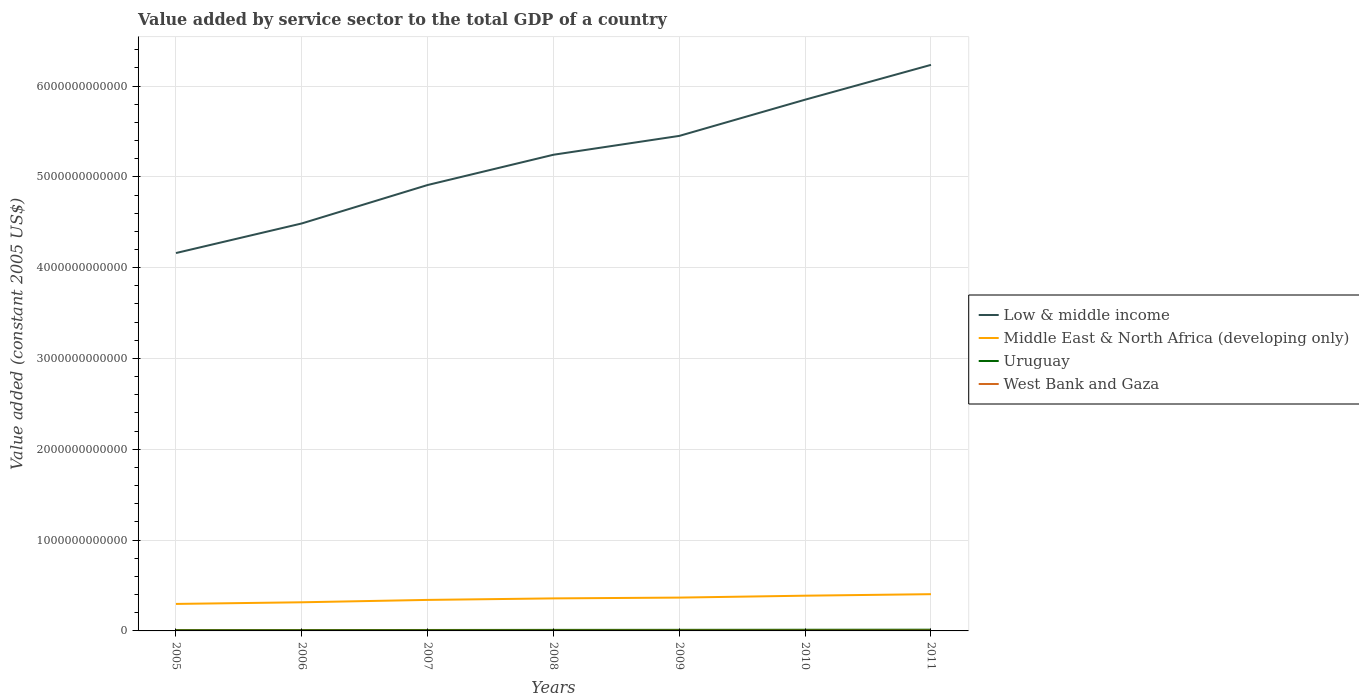Across all years, what is the maximum value added by service sector in Uruguay?
Provide a short and direct response. 9.41e+09. What is the total value added by service sector in Low & middle income in the graph?
Give a very brief answer. -9.40e+11. What is the difference between the highest and the second highest value added by service sector in Low & middle income?
Ensure brevity in your answer.  2.07e+12. What is the difference between the highest and the lowest value added by service sector in Middle East & North Africa (developing only)?
Ensure brevity in your answer.  4. Is the value added by service sector in West Bank and Gaza strictly greater than the value added by service sector in Middle East & North Africa (developing only) over the years?
Your answer should be very brief. Yes. What is the difference between two consecutive major ticks on the Y-axis?
Keep it short and to the point. 1.00e+12. Are the values on the major ticks of Y-axis written in scientific E-notation?
Offer a terse response. No. Does the graph contain grids?
Provide a succinct answer. Yes. Where does the legend appear in the graph?
Your answer should be very brief. Center right. How many legend labels are there?
Ensure brevity in your answer.  4. How are the legend labels stacked?
Your answer should be very brief. Vertical. What is the title of the graph?
Your response must be concise. Value added by service sector to the total GDP of a country. What is the label or title of the Y-axis?
Your answer should be very brief. Value added (constant 2005 US$). What is the Value added (constant 2005 US$) in Low & middle income in 2005?
Provide a succinct answer. 4.16e+12. What is the Value added (constant 2005 US$) of Middle East & North Africa (developing only) in 2005?
Provide a short and direct response. 2.97e+11. What is the Value added (constant 2005 US$) of Uruguay in 2005?
Give a very brief answer. 9.41e+09. What is the Value added (constant 2005 US$) of West Bank and Gaza in 2005?
Offer a terse response. 2.81e+09. What is the Value added (constant 2005 US$) of Low & middle income in 2006?
Give a very brief answer. 4.49e+12. What is the Value added (constant 2005 US$) of Middle East & North Africa (developing only) in 2006?
Make the answer very short. 3.15e+11. What is the Value added (constant 2005 US$) of Uruguay in 2006?
Make the answer very short. 9.68e+09. What is the Value added (constant 2005 US$) in West Bank and Gaza in 2006?
Ensure brevity in your answer.  2.79e+09. What is the Value added (constant 2005 US$) of Low & middle income in 2007?
Your answer should be compact. 4.91e+12. What is the Value added (constant 2005 US$) of Middle East & North Africa (developing only) in 2007?
Offer a very short reply. 3.42e+11. What is the Value added (constant 2005 US$) of Uruguay in 2007?
Provide a succinct answer. 1.03e+1. What is the Value added (constant 2005 US$) in West Bank and Gaza in 2007?
Your answer should be compact. 2.63e+09. What is the Value added (constant 2005 US$) of Low & middle income in 2008?
Keep it short and to the point. 5.24e+12. What is the Value added (constant 2005 US$) of Middle East & North Africa (developing only) in 2008?
Your answer should be very brief. 3.58e+11. What is the Value added (constant 2005 US$) of Uruguay in 2008?
Provide a succinct answer. 1.13e+1. What is the Value added (constant 2005 US$) in West Bank and Gaza in 2008?
Provide a short and direct response. 2.28e+09. What is the Value added (constant 2005 US$) in Low & middle income in 2009?
Ensure brevity in your answer.  5.45e+12. What is the Value added (constant 2005 US$) of Middle East & North Africa (developing only) in 2009?
Your answer should be very brief. 3.67e+11. What is the Value added (constant 2005 US$) in Uruguay in 2009?
Offer a very short reply. 1.18e+1. What is the Value added (constant 2005 US$) of West Bank and Gaza in 2009?
Make the answer very short. 2.69e+09. What is the Value added (constant 2005 US$) of Low & middle income in 2010?
Make the answer very short. 5.85e+12. What is the Value added (constant 2005 US$) of Middle East & North Africa (developing only) in 2010?
Your response must be concise. 3.88e+11. What is the Value added (constant 2005 US$) in Uruguay in 2010?
Your response must be concise. 1.27e+1. What is the Value added (constant 2005 US$) of West Bank and Gaza in 2010?
Offer a very short reply. 2.80e+09. What is the Value added (constant 2005 US$) in Low & middle income in 2011?
Give a very brief answer. 6.23e+12. What is the Value added (constant 2005 US$) in Middle East & North Africa (developing only) in 2011?
Give a very brief answer. 4.05e+11. What is the Value added (constant 2005 US$) in Uruguay in 2011?
Ensure brevity in your answer.  1.34e+1. What is the Value added (constant 2005 US$) in West Bank and Gaza in 2011?
Ensure brevity in your answer.  3.15e+09. Across all years, what is the maximum Value added (constant 2005 US$) in Low & middle income?
Make the answer very short. 6.23e+12. Across all years, what is the maximum Value added (constant 2005 US$) of Middle East & North Africa (developing only)?
Your response must be concise. 4.05e+11. Across all years, what is the maximum Value added (constant 2005 US$) of Uruguay?
Keep it short and to the point. 1.34e+1. Across all years, what is the maximum Value added (constant 2005 US$) of West Bank and Gaza?
Provide a short and direct response. 3.15e+09. Across all years, what is the minimum Value added (constant 2005 US$) in Low & middle income?
Provide a succinct answer. 4.16e+12. Across all years, what is the minimum Value added (constant 2005 US$) of Middle East & North Africa (developing only)?
Give a very brief answer. 2.97e+11. Across all years, what is the minimum Value added (constant 2005 US$) of Uruguay?
Your response must be concise. 9.41e+09. Across all years, what is the minimum Value added (constant 2005 US$) of West Bank and Gaza?
Keep it short and to the point. 2.28e+09. What is the total Value added (constant 2005 US$) in Low & middle income in the graph?
Give a very brief answer. 3.63e+13. What is the total Value added (constant 2005 US$) in Middle East & North Africa (developing only) in the graph?
Your response must be concise. 2.47e+12. What is the total Value added (constant 2005 US$) in Uruguay in the graph?
Give a very brief answer. 7.85e+1. What is the total Value added (constant 2005 US$) of West Bank and Gaza in the graph?
Provide a succinct answer. 1.92e+1. What is the difference between the Value added (constant 2005 US$) of Low & middle income in 2005 and that in 2006?
Offer a terse response. -3.26e+11. What is the difference between the Value added (constant 2005 US$) of Middle East & North Africa (developing only) in 2005 and that in 2006?
Provide a short and direct response. -1.81e+1. What is the difference between the Value added (constant 2005 US$) in Uruguay in 2005 and that in 2006?
Your answer should be very brief. -2.69e+08. What is the difference between the Value added (constant 2005 US$) in West Bank and Gaza in 2005 and that in 2006?
Make the answer very short. 2.14e+07. What is the difference between the Value added (constant 2005 US$) in Low & middle income in 2005 and that in 2007?
Your answer should be compact. -7.49e+11. What is the difference between the Value added (constant 2005 US$) in Middle East & North Africa (developing only) in 2005 and that in 2007?
Provide a succinct answer. -4.43e+1. What is the difference between the Value added (constant 2005 US$) of Uruguay in 2005 and that in 2007?
Your answer should be compact. -8.47e+08. What is the difference between the Value added (constant 2005 US$) of West Bank and Gaza in 2005 and that in 2007?
Your answer should be very brief. 1.74e+08. What is the difference between the Value added (constant 2005 US$) of Low & middle income in 2005 and that in 2008?
Provide a short and direct response. -1.08e+12. What is the difference between the Value added (constant 2005 US$) of Middle East & North Africa (developing only) in 2005 and that in 2008?
Offer a terse response. -6.09e+1. What is the difference between the Value added (constant 2005 US$) in Uruguay in 2005 and that in 2008?
Provide a short and direct response. -1.88e+09. What is the difference between the Value added (constant 2005 US$) of West Bank and Gaza in 2005 and that in 2008?
Provide a short and direct response. 5.28e+08. What is the difference between the Value added (constant 2005 US$) in Low & middle income in 2005 and that in 2009?
Your answer should be compact. -1.29e+12. What is the difference between the Value added (constant 2005 US$) in Middle East & North Africa (developing only) in 2005 and that in 2009?
Offer a very short reply. -6.96e+1. What is the difference between the Value added (constant 2005 US$) of Uruguay in 2005 and that in 2009?
Ensure brevity in your answer.  -2.40e+09. What is the difference between the Value added (constant 2005 US$) in West Bank and Gaza in 2005 and that in 2009?
Give a very brief answer. 1.14e+08. What is the difference between the Value added (constant 2005 US$) of Low & middle income in 2005 and that in 2010?
Offer a very short reply. -1.69e+12. What is the difference between the Value added (constant 2005 US$) of Middle East & North Africa (developing only) in 2005 and that in 2010?
Your answer should be very brief. -9.07e+1. What is the difference between the Value added (constant 2005 US$) in Uruguay in 2005 and that in 2010?
Provide a succinct answer. -3.27e+09. What is the difference between the Value added (constant 2005 US$) in West Bank and Gaza in 2005 and that in 2010?
Keep it short and to the point. 2.78e+06. What is the difference between the Value added (constant 2005 US$) in Low & middle income in 2005 and that in 2011?
Offer a very short reply. -2.07e+12. What is the difference between the Value added (constant 2005 US$) of Middle East & North Africa (developing only) in 2005 and that in 2011?
Keep it short and to the point. -1.07e+11. What is the difference between the Value added (constant 2005 US$) of Uruguay in 2005 and that in 2011?
Make the answer very short. -3.97e+09. What is the difference between the Value added (constant 2005 US$) of West Bank and Gaza in 2005 and that in 2011?
Make the answer very short. -3.43e+08. What is the difference between the Value added (constant 2005 US$) of Low & middle income in 2006 and that in 2007?
Your response must be concise. -4.23e+11. What is the difference between the Value added (constant 2005 US$) of Middle East & North Africa (developing only) in 2006 and that in 2007?
Ensure brevity in your answer.  -2.62e+1. What is the difference between the Value added (constant 2005 US$) of Uruguay in 2006 and that in 2007?
Provide a succinct answer. -5.78e+08. What is the difference between the Value added (constant 2005 US$) of West Bank and Gaza in 2006 and that in 2007?
Make the answer very short. 1.53e+08. What is the difference between the Value added (constant 2005 US$) of Low & middle income in 2006 and that in 2008?
Give a very brief answer. -7.56e+11. What is the difference between the Value added (constant 2005 US$) in Middle East & North Africa (developing only) in 2006 and that in 2008?
Provide a succinct answer. -4.29e+1. What is the difference between the Value added (constant 2005 US$) in Uruguay in 2006 and that in 2008?
Provide a short and direct response. -1.61e+09. What is the difference between the Value added (constant 2005 US$) of West Bank and Gaza in 2006 and that in 2008?
Your answer should be very brief. 5.07e+08. What is the difference between the Value added (constant 2005 US$) in Low & middle income in 2006 and that in 2009?
Offer a very short reply. -9.64e+11. What is the difference between the Value added (constant 2005 US$) in Middle East & North Africa (developing only) in 2006 and that in 2009?
Offer a very short reply. -5.15e+1. What is the difference between the Value added (constant 2005 US$) in Uruguay in 2006 and that in 2009?
Your answer should be very brief. -2.13e+09. What is the difference between the Value added (constant 2005 US$) of West Bank and Gaza in 2006 and that in 2009?
Keep it short and to the point. 9.29e+07. What is the difference between the Value added (constant 2005 US$) in Low & middle income in 2006 and that in 2010?
Offer a very short reply. -1.36e+12. What is the difference between the Value added (constant 2005 US$) in Middle East & North Africa (developing only) in 2006 and that in 2010?
Your answer should be compact. -7.27e+1. What is the difference between the Value added (constant 2005 US$) of Uruguay in 2006 and that in 2010?
Ensure brevity in your answer.  -3.00e+09. What is the difference between the Value added (constant 2005 US$) in West Bank and Gaza in 2006 and that in 2010?
Provide a short and direct response. -1.87e+07. What is the difference between the Value added (constant 2005 US$) in Low & middle income in 2006 and that in 2011?
Keep it short and to the point. -1.75e+12. What is the difference between the Value added (constant 2005 US$) in Middle East & North Africa (developing only) in 2006 and that in 2011?
Ensure brevity in your answer.  -8.93e+1. What is the difference between the Value added (constant 2005 US$) in Uruguay in 2006 and that in 2011?
Your answer should be compact. -3.70e+09. What is the difference between the Value added (constant 2005 US$) in West Bank and Gaza in 2006 and that in 2011?
Your answer should be compact. -3.64e+08. What is the difference between the Value added (constant 2005 US$) of Low & middle income in 2007 and that in 2008?
Make the answer very short. -3.33e+11. What is the difference between the Value added (constant 2005 US$) of Middle East & North Africa (developing only) in 2007 and that in 2008?
Provide a succinct answer. -1.67e+1. What is the difference between the Value added (constant 2005 US$) of Uruguay in 2007 and that in 2008?
Your answer should be very brief. -1.04e+09. What is the difference between the Value added (constant 2005 US$) of West Bank and Gaza in 2007 and that in 2008?
Your answer should be very brief. 3.54e+08. What is the difference between the Value added (constant 2005 US$) of Low & middle income in 2007 and that in 2009?
Offer a terse response. -5.41e+11. What is the difference between the Value added (constant 2005 US$) in Middle East & North Africa (developing only) in 2007 and that in 2009?
Provide a succinct answer. -2.53e+1. What is the difference between the Value added (constant 2005 US$) of Uruguay in 2007 and that in 2009?
Make the answer very short. -1.55e+09. What is the difference between the Value added (constant 2005 US$) in West Bank and Gaza in 2007 and that in 2009?
Ensure brevity in your answer.  -5.98e+07. What is the difference between the Value added (constant 2005 US$) in Low & middle income in 2007 and that in 2010?
Keep it short and to the point. -9.40e+11. What is the difference between the Value added (constant 2005 US$) of Middle East & North Africa (developing only) in 2007 and that in 2010?
Offer a terse response. -4.65e+1. What is the difference between the Value added (constant 2005 US$) in Uruguay in 2007 and that in 2010?
Provide a succinct answer. -2.42e+09. What is the difference between the Value added (constant 2005 US$) of West Bank and Gaza in 2007 and that in 2010?
Your answer should be compact. -1.71e+08. What is the difference between the Value added (constant 2005 US$) of Low & middle income in 2007 and that in 2011?
Offer a very short reply. -1.32e+12. What is the difference between the Value added (constant 2005 US$) in Middle East & North Africa (developing only) in 2007 and that in 2011?
Offer a terse response. -6.31e+1. What is the difference between the Value added (constant 2005 US$) in Uruguay in 2007 and that in 2011?
Ensure brevity in your answer.  -3.13e+09. What is the difference between the Value added (constant 2005 US$) in West Bank and Gaza in 2007 and that in 2011?
Ensure brevity in your answer.  -5.17e+08. What is the difference between the Value added (constant 2005 US$) in Low & middle income in 2008 and that in 2009?
Offer a terse response. -2.08e+11. What is the difference between the Value added (constant 2005 US$) of Middle East & North Africa (developing only) in 2008 and that in 2009?
Your answer should be very brief. -8.68e+09. What is the difference between the Value added (constant 2005 US$) in Uruguay in 2008 and that in 2009?
Provide a short and direct response. -5.17e+08. What is the difference between the Value added (constant 2005 US$) of West Bank and Gaza in 2008 and that in 2009?
Ensure brevity in your answer.  -4.14e+08. What is the difference between the Value added (constant 2005 US$) in Low & middle income in 2008 and that in 2010?
Give a very brief answer. -6.06e+11. What is the difference between the Value added (constant 2005 US$) of Middle East & North Africa (developing only) in 2008 and that in 2010?
Your answer should be very brief. -2.98e+1. What is the difference between the Value added (constant 2005 US$) of Uruguay in 2008 and that in 2010?
Your answer should be compact. -1.38e+09. What is the difference between the Value added (constant 2005 US$) in West Bank and Gaza in 2008 and that in 2010?
Offer a terse response. -5.26e+08. What is the difference between the Value added (constant 2005 US$) of Low & middle income in 2008 and that in 2011?
Offer a very short reply. -9.90e+11. What is the difference between the Value added (constant 2005 US$) of Middle East & North Africa (developing only) in 2008 and that in 2011?
Offer a very short reply. -4.64e+1. What is the difference between the Value added (constant 2005 US$) of Uruguay in 2008 and that in 2011?
Provide a short and direct response. -2.09e+09. What is the difference between the Value added (constant 2005 US$) in West Bank and Gaza in 2008 and that in 2011?
Provide a short and direct response. -8.71e+08. What is the difference between the Value added (constant 2005 US$) in Low & middle income in 2009 and that in 2010?
Ensure brevity in your answer.  -3.99e+11. What is the difference between the Value added (constant 2005 US$) in Middle East & North Africa (developing only) in 2009 and that in 2010?
Provide a succinct answer. -2.12e+1. What is the difference between the Value added (constant 2005 US$) of Uruguay in 2009 and that in 2010?
Offer a terse response. -8.67e+08. What is the difference between the Value added (constant 2005 US$) of West Bank and Gaza in 2009 and that in 2010?
Ensure brevity in your answer.  -1.12e+08. What is the difference between the Value added (constant 2005 US$) of Low & middle income in 2009 and that in 2011?
Offer a terse response. -7.82e+11. What is the difference between the Value added (constant 2005 US$) in Middle East & North Africa (developing only) in 2009 and that in 2011?
Provide a succinct answer. -3.78e+1. What is the difference between the Value added (constant 2005 US$) of Uruguay in 2009 and that in 2011?
Provide a succinct answer. -1.57e+09. What is the difference between the Value added (constant 2005 US$) of West Bank and Gaza in 2009 and that in 2011?
Provide a short and direct response. -4.57e+08. What is the difference between the Value added (constant 2005 US$) of Low & middle income in 2010 and that in 2011?
Offer a terse response. -3.83e+11. What is the difference between the Value added (constant 2005 US$) in Middle East & North Africa (developing only) in 2010 and that in 2011?
Provide a short and direct response. -1.66e+1. What is the difference between the Value added (constant 2005 US$) of Uruguay in 2010 and that in 2011?
Your answer should be compact. -7.06e+08. What is the difference between the Value added (constant 2005 US$) in West Bank and Gaza in 2010 and that in 2011?
Give a very brief answer. -3.45e+08. What is the difference between the Value added (constant 2005 US$) in Low & middle income in 2005 and the Value added (constant 2005 US$) in Middle East & North Africa (developing only) in 2006?
Keep it short and to the point. 3.85e+12. What is the difference between the Value added (constant 2005 US$) of Low & middle income in 2005 and the Value added (constant 2005 US$) of Uruguay in 2006?
Make the answer very short. 4.15e+12. What is the difference between the Value added (constant 2005 US$) of Low & middle income in 2005 and the Value added (constant 2005 US$) of West Bank and Gaza in 2006?
Offer a terse response. 4.16e+12. What is the difference between the Value added (constant 2005 US$) in Middle East & North Africa (developing only) in 2005 and the Value added (constant 2005 US$) in Uruguay in 2006?
Make the answer very short. 2.88e+11. What is the difference between the Value added (constant 2005 US$) in Middle East & North Africa (developing only) in 2005 and the Value added (constant 2005 US$) in West Bank and Gaza in 2006?
Your answer should be compact. 2.95e+11. What is the difference between the Value added (constant 2005 US$) in Uruguay in 2005 and the Value added (constant 2005 US$) in West Bank and Gaza in 2006?
Provide a succinct answer. 6.62e+09. What is the difference between the Value added (constant 2005 US$) in Low & middle income in 2005 and the Value added (constant 2005 US$) in Middle East & North Africa (developing only) in 2007?
Keep it short and to the point. 3.82e+12. What is the difference between the Value added (constant 2005 US$) in Low & middle income in 2005 and the Value added (constant 2005 US$) in Uruguay in 2007?
Give a very brief answer. 4.15e+12. What is the difference between the Value added (constant 2005 US$) of Low & middle income in 2005 and the Value added (constant 2005 US$) of West Bank and Gaza in 2007?
Make the answer very short. 4.16e+12. What is the difference between the Value added (constant 2005 US$) in Middle East & North Africa (developing only) in 2005 and the Value added (constant 2005 US$) in Uruguay in 2007?
Offer a very short reply. 2.87e+11. What is the difference between the Value added (constant 2005 US$) in Middle East & North Africa (developing only) in 2005 and the Value added (constant 2005 US$) in West Bank and Gaza in 2007?
Keep it short and to the point. 2.95e+11. What is the difference between the Value added (constant 2005 US$) of Uruguay in 2005 and the Value added (constant 2005 US$) of West Bank and Gaza in 2007?
Offer a very short reply. 6.78e+09. What is the difference between the Value added (constant 2005 US$) of Low & middle income in 2005 and the Value added (constant 2005 US$) of Middle East & North Africa (developing only) in 2008?
Offer a terse response. 3.80e+12. What is the difference between the Value added (constant 2005 US$) in Low & middle income in 2005 and the Value added (constant 2005 US$) in Uruguay in 2008?
Your response must be concise. 4.15e+12. What is the difference between the Value added (constant 2005 US$) of Low & middle income in 2005 and the Value added (constant 2005 US$) of West Bank and Gaza in 2008?
Your answer should be very brief. 4.16e+12. What is the difference between the Value added (constant 2005 US$) of Middle East & North Africa (developing only) in 2005 and the Value added (constant 2005 US$) of Uruguay in 2008?
Your answer should be very brief. 2.86e+11. What is the difference between the Value added (constant 2005 US$) in Middle East & North Africa (developing only) in 2005 and the Value added (constant 2005 US$) in West Bank and Gaza in 2008?
Make the answer very short. 2.95e+11. What is the difference between the Value added (constant 2005 US$) of Uruguay in 2005 and the Value added (constant 2005 US$) of West Bank and Gaza in 2008?
Give a very brief answer. 7.13e+09. What is the difference between the Value added (constant 2005 US$) in Low & middle income in 2005 and the Value added (constant 2005 US$) in Middle East & North Africa (developing only) in 2009?
Your response must be concise. 3.79e+12. What is the difference between the Value added (constant 2005 US$) in Low & middle income in 2005 and the Value added (constant 2005 US$) in Uruguay in 2009?
Offer a terse response. 4.15e+12. What is the difference between the Value added (constant 2005 US$) of Low & middle income in 2005 and the Value added (constant 2005 US$) of West Bank and Gaza in 2009?
Keep it short and to the point. 4.16e+12. What is the difference between the Value added (constant 2005 US$) in Middle East & North Africa (developing only) in 2005 and the Value added (constant 2005 US$) in Uruguay in 2009?
Ensure brevity in your answer.  2.85e+11. What is the difference between the Value added (constant 2005 US$) of Middle East & North Africa (developing only) in 2005 and the Value added (constant 2005 US$) of West Bank and Gaza in 2009?
Your answer should be very brief. 2.95e+11. What is the difference between the Value added (constant 2005 US$) in Uruguay in 2005 and the Value added (constant 2005 US$) in West Bank and Gaza in 2009?
Make the answer very short. 6.72e+09. What is the difference between the Value added (constant 2005 US$) in Low & middle income in 2005 and the Value added (constant 2005 US$) in Middle East & North Africa (developing only) in 2010?
Make the answer very short. 3.77e+12. What is the difference between the Value added (constant 2005 US$) of Low & middle income in 2005 and the Value added (constant 2005 US$) of Uruguay in 2010?
Your answer should be very brief. 4.15e+12. What is the difference between the Value added (constant 2005 US$) of Low & middle income in 2005 and the Value added (constant 2005 US$) of West Bank and Gaza in 2010?
Your answer should be very brief. 4.16e+12. What is the difference between the Value added (constant 2005 US$) in Middle East & North Africa (developing only) in 2005 and the Value added (constant 2005 US$) in Uruguay in 2010?
Keep it short and to the point. 2.85e+11. What is the difference between the Value added (constant 2005 US$) of Middle East & North Africa (developing only) in 2005 and the Value added (constant 2005 US$) of West Bank and Gaza in 2010?
Make the answer very short. 2.95e+11. What is the difference between the Value added (constant 2005 US$) in Uruguay in 2005 and the Value added (constant 2005 US$) in West Bank and Gaza in 2010?
Provide a succinct answer. 6.61e+09. What is the difference between the Value added (constant 2005 US$) of Low & middle income in 2005 and the Value added (constant 2005 US$) of Middle East & North Africa (developing only) in 2011?
Keep it short and to the point. 3.76e+12. What is the difference between the Value added (constant 2005 US$) in Low & middle income in 2005 and the Value added (constant 2005 US$) in Uruguay in 2011?
Ensure brevity in your answer.  4.15e+12. What is the difference between the Value added (constant 2005 US$) in Low & middle income in 2005 and the Value added (constant 2005 US$) in West Bank and Gaza in 2011?
Make the answer very short. 4.16e+12. What is the difference between the Value added (constant 2005 US$) in Middle East & North Africa (developing only) in 2005 and the Value added (constant 2005 US$) in Uruguay in 2011?
Keep it short and to the point. 2.84e+11. What is the difference between the Value added (constant 2005 US$) of Middle East & North Africa (developing only) in 2005 and the Value added (constant 2005 US$) of West Bank and Gaza in 2011?
Offer a very short reply. 2.94e+11. What is the difference between the Value added (constant 2005 US$) of Uruguay in 2005 and the Value added (constant 2005 US$) of West Bank and Gaza in 2011?
Give a very brief answer. 6.26e+09. What is the difference between the Value added (constant 2005 US$) of Low & middle income in 2006 and the Value added (constant 2005 US$) of Middle East & North Africa (developing only) in 2007?
Keep it short and to the point. 4.15e+12. What is the difference between the Value added (constant 2005 US$) in Low & middle income in 2006 and the Value added (constant 2005 US$) in Uruguay in 2007?
Provide a short and direct response. 4.48e+12. What is the difference between the Value added (constant 2005 US$) in Low & middle income in 2006 and the Value added (constant 2005 US$) in West Bank and Gaza in 2007?
Offer a very short reply. 4.48e+12. What is the difference between the Value added (constant 2005 US$) of Middle East & North Africa (developing only) in 2006 and the Value added (constant 2005 US$) of Uruguay in 2007?
Keep it short and to the point. 3.05e+11. What is the difference between the Value added (constant 2005 US$) of Middle East & North Africa (developing only) in 2006 and the Value added (constant 2005 US$) of West Bank and Gaza in 2007?
Offer a terse response. 3.13e+11. What is the difference between the Value added (constant 2005 US$) of Uruguay in 2006 and the Value added (constant 2005 US$) of West Bank and Gaza in 2007?
Make the answer very short. 7.05e+09. What is the difference between the Value added (constant 2005 US$) of Low & middle income in 2006 and the Value added (constant 2005 US$) of Middle East & North Africa (developing only) in 2008?
Your response must be concise. 4.13e+12. What is the difference between the Value added (constant 2005 US$) of Low & middle income in 2006 and the Value added (constant 2005 US$) of Uruguay in 2008?
Offer a very short reply. 4.48e+12. What is the difference between the Value added (constant 2005 US$) of Low & middle income in 2006 and the Value added (constant 2005 US$) of West Bank and Gaza in 2008?
Ensure brevity in your answer.  4.48e+12. What is the difference between the Value added (constant 2005 US$) in Middle East & North Africa (developing only) in 2006 and the Value added (constant 2005 US$) in Uruguay in 2008?
Give a very brief answer. 3.04e+11. What is the difference between the Value added (constant 2005 US$) in Middle East & North Africa (developing only) in 2006 and the Value added (constant 2005 US$) in West Bank and Gaza in 2008?
Offer a terse response. 3.13e+11. What is the difference between the Value added (constant 2005 US$) of Uruguay in 2006 and the Value added (constant 2005 US$) of West Bank and Gaza in 2008?
Give a very brief answer. 7.40e+09. What is the difference between the Value added (constant 2005 US$) in Low & middle income in 2006 and the Value added (constant 2005 US$) in Middle East & North Africa (developing only) in 2009?
Offer a very short reply. 4.12e+12. What is the difference between the Value added (constant 2005 US$) of Low & middle income in 2006 and the Value added (constant 2005 US$) of Uruguay in 2009?
Provide a succinct answer. 4.48e+12. What is the difference between the Value added (constant 2005 US$) of Low & middle income in 2006 and the Value added (constant 2005 US$) of West Bank and Gaza in 2009?
Offer a very short reply. 4.48e+12. What is the difference between the Value added (constant 2005 US$) in Middle East & North Africa (developing only) in 2006 and the Value added (constant 2005 US$) in Uruguay in 2009?
Keep it short and to the point. 3.04e+11. What is the difference between the Value added (constant 2005 US$) of Middle East & North Africa (developing only) in 2006 and the Value added (constant 2005 US$) of West Bank and Gaza in 2009?
Offer a very short reply. 3.13e+11. What is the difference between the Value added (constant 2005 US$) of Uruguay in 2006 and the Value added (constant 2005 US$) of West Bank and Gaza in 2009?
Ensure brevity in your answer.  6.99e+09. What is the difference between the Value added (constant 2005 US$) in Low & middle income in 2006 and the Value added (constant 2005 US$) in Middle East & North Africa (developing only) in 2010?
Provide a succinct answer. 4.10e+12. What is the difference between the Value added (constant 2005 US$) in Low & middle income in 2006 and the Value added (constant 2005 US$) in Uruguay in 2010?
Make the answer very short. 4.47e+12. What is the difference between the Value added (constant 2005 US$) in Low & middle income in 2006 and the Value added (constant 2005 US$) in West Bank and Gaza in 2010?
Keep it short and to the point. 4.48e+12. What is the difference between the Value added (constant 2005 US$) of Middle East & North Africa (developing only) in 2006 and the Value added (constant 2005 US$) of Uruguay in 2010?
Offer a terse response. 3.03e+11. What is the difference between the Value added (constant 2005 US$) of Middle East & North Africa (developing only) in 2006 and the Value added (constant 2005 US$) of West Bank and Gaza in 2010?
Offer a very short reply. 3.13e+11. What is the difference between the Value added (constant 2005 US$) of Uruguay in 2006 and the Value added (constant 2005 US$) of West Bank and Gaza in 2010?
Your answer should be very brief. 6.87e+09. What is the difference between the Value added (constant 2005 US$) of Low & middle income in 2006 and the Value added (constant 2005 US$) of Middle East & North Africa (developing only) in 2011?
Provide a short and direct response. 4.08e+12. What is the difference between the Value added (constant 2005 US$) in Low & middle income in 2006 and the Value added (constant 2005 US$) in Uruguay in 2011?
Keep it short and to the point. 4.47e+12. What is the difference between the Value added (constant 2005 US$) in Low & middle income in 2006 and the Value added (constant 2005 US$) in West Bank and Gaza in 2011?
Provide a short and direct response. 4.48e+12. What is the difference between the Value added (constant 2005 US$) of Middle East & North Africa (developing only) in 2006 and the Value added (constant 2005 US$) of Uruguay in 2011?
Offer a terse response. 3.02e+11. What is the difference between the Value added (constant 2005 US$) of Middle East & North Africa (developing only) in 2006 and the Value added (constant 2005 US$) of West Bank and Gaza in 2011?
Your answer should be compact. 3.12e+11. What is the difference between the Value added (constant 2005 US$) in Uruguay in 2006 and the Value added (constant 2005 US$) in West Bank and Gaza in 2011?
Provide a succinct answer. 6.53e+09. What is the difference between the Value added (constant 2005 US$) in Low & middle income in 2007 and the Value added (constant 2005 US$) in Middle East & North Africa (developing only) in 2008?
Provide a short and direct response. 4.55e+12. What is the difference between the Value added (constant 2005 US$) in Low & middle income in 2007 and the Value added (constant 2005 US$) in Uruguay in 2008?
Your answer should be compact. 4.90e+12. What is the difference between the Value added (constant 2005 US$) of Low & middle income in 2007 and the Value added (constant 2005 US$) of West Bank and Gaza in 2008?
Ensure brevity in your answer.  4.91e+12. What is the difference between the Value added (constant 2005 US$) in Middle East & North Africa (developing only) in 2007 and the Value added (constant 2005 US$) in Uruguay in 2008?
Provide a short and direct response. 3.30e+11. What is the difference between the Value added (constant 2005 US$) in Middle East & North Africa (developing only) in 2007 and the Value added (constant 2005 US$) in West Bank and Gaza in 2008?
Give a very brief answer. 3.39e+11. What is the difference between the Value added (constant 2005 US$) of Uruguay in 2007 and the Value added (constant 2005 US$) of West Bank and Gaza in 2008?
Give a very brief answer. 7.98e+09. What is the difference between the Value added (constant 2005 US$) of Low & middle income in 2007 and the Value added (constant 2005 US$) of Middle East & North Africa (developing only) in 2009?
Offer a very short reply. 4.54e+12. What is the difference between the Value added (constant 2005 US$) of Low & middle income in 2007 and the Value added (constant 2005 US$) of Uruguay in 2009?
Provide a succinct answer. 4.90e+12. What is the difference between the Value added (constant 2005 US$) in Low & middle income in 2007 and the Value added (constant 2005 US$) in West Bank and Gaza in 2009?
Offer a very short reply. 4.91e+12. What is the difference between the Value added (constant 2005 US$) of Middle East & North Africa (developing only) in 2007 and the Value added (constant 2005 US$) of Uruguay in 2009?
Provide a succinct answer. 3.30e+11. What is the difference between the Value added (constant 2005 US$) in Middle East & North Africa (developing only) in 2007 and the Value added (constant 2005 US$) in West Bank and Gaza in 2009?
Ensure brevity in your answer.  3.39e+11. What is the difference between the Value added (constant 2005 US$) of Uruguay in 2007 and the Value added (constant 2005 US$) of West Bank and Gaza in 2009?
Give a very brief answer. 7.56e+09. What is the difference between the Value added (constant 2005 US$) of Low & middle income in 2007 and the Value added (constant 2005 US$) of Middle East & North Africa (developing only) in 2010?
Keep it short and to the point. 4.52e+12. What is the difference between the Value added (constant 2005 US$) of Low & middle income in 2007 and the Value added (constant 2005 US$) of Uruguay in 2010?
Offer a terse response. 4.90e+12. What is the difference between the Value added (constant 2005 US$) of Low & middle income in 2007 and the Value added (constant 2005 US$) of West Bank and Gaza in 2010?
Provide a short and direct response. 4.91e+12. What is the difference between the Value added (constant 2005 US$) in Middle East & North Africa (developing only) in 2007 and the Value added (constant 2005 US$) in Uruguay in 2010?
Your answer should be very brief. 3.29e+11. What is the difference between the Value added (constant 2005 US$) of Middle East & North Africa (developing only) in 2007 and the Value added (constant 2005 US$) of West Bank and Gaza in 2010?
Ensure brevity in your answer.  3.39e+11. What is the difference between the Value added (constant 2005 US$) in Uruguay in 2007 and the Value added (constant 2005 US$) in West Bank and Gaza in 2010?
Make the answer very short. 7.45e+09. What is the difference between the Value added (constant 2005 US$) of Low & middle income in 2007 and the Value added (constant 2005 US$) of Middle East & North Africa (developing only) in 2011?
Make the answer very short. 4.51e+12. What is the difference between the Value added (constant 2005 US$) of Low & middle income in 2007 and the Value added (constant 2005 US$) of Uruguay in 2011?
Keep it short and to the point. 4.90e+12. What is the difference between the Value added (constant 2005 US$) in Low & middle income in 2007 and the Value added (constant 2005 US$) in West Bank and Gaza in 2011?
Provide a short and direct response. 4.91e+12. What is the difference between the Value added (constant 2005 US$) in Middle East & North Africa (developing only) in 2007 and the Value added (constant 2005 US$) in Uruguay in 2011?
Give a very brief answer. 3.28e+11. What is the difference between the Value added (constant 2005 US$) of Middle East & North Africa (developing only) in 2007 and the Value added (constant 2005 US$) of West Bank and Gaza in 2011?
Provide a short and direct response. 3.38e+11. What is the difference between the Value added (constant 2005 US$) in Uruguay in 2007 and the Value added (constant 2005 US$) in West Bank and Gaza in 2011?
Your response must be concise. 7.11e+09. What is the difference between the Value added (constant 2005 US$) of Low & middle income in 2008 and the Value added (constant 2005 US$) of Middle East & North Africa (developing only) in 2009?
Your answer should be compact. 4.88e+12. What is the difference between the Value added (constant 2005 US$) of Low & middle income in 2008 and the Value added (constant 2005 US$) of Uruguay in 2009?
Your response must be concise. 5.23e+12. What is the difference between the Value added (constant 2005 US$) of Low & middle income in 2008 and the Value added (constant 2005 US$) of West Bank and Gaza in 2009?
Your response must be concise. 5.24e+12. What is the difference between the Value added (constant 2005 US$) of Middle East & North Africa (developing only) in 2008 and the Value added (constant 2005 US$) of Uruguay in 2009?
Offer a very short reply. 3.46e+11. What is the difference between the Value added (constant 2005 US$) of Middle East & North Africa (developing only) in 2008 and the Value added (constant 2005 US$) of West Bank and Gaza in 2009?
Offer a very short reply. 3.56e+11. What is the difference between the Value added (constant 2005 US$) of Uruguay in 2008 and the Value added (constant 2005 US$) of West Bank and Gaza in 2009?
Give a very brief answer. 8.60e+09. What is the difference between the Value added (constant 2005 US$) of Low & middle income in 2008 and the Value added (constant 2005 US$) of Middle East & North Africa (developing only) in 2010?
Your response must be concise. 4.86e+12. What is the difference between the Value added (constant 2005 US$) in Low & middle income in 2008 and the Value added (constant 2005 US$) in Uruguay in 2010?
Make the answer very short. 5.23e+12. What is the difference between the Value added (constant 2005 US$) of Low & middle income in 2008 and the Value added (constant 2005 US$) of West Bank and Gaza in 2010?
Your answer should be compact. 5.24e+12. What is the difference between the Value added (constant 2005 US$) of Middle East & North Africa (developing only) in 2008 and the Value added (constant 2005 US$) of Uruguay in 2010?
Offer a terse response. 3.46e+11. What is the difference between the Value added (constant 2005 US$) of Middle East & North Africa (developing only) in 2008 and the Value added (constant 2005 US$) of West Bank and Gaza in 2010?
Keep it short and to the point. 3.55e+11. What is the difference between the Value added (constant 2005 US$) of Uruguay in 2008 and the Value added (constant 2005 US$) of West Bank and Gaza in 2010?
Keep it short and to the point. 8.49e+09. What is the difference between the Value added (constant 2005 US$) of Low & middle income in 2008 and the Value added (constant 2005 US$) of Middle East & North Africa (developing only) in 2011?
Your response must be concise. 4.84e+12. What is the difference between the Value added (constant 2005 US$) of Low & middle income in 2008 and the Value added (constant 2005 US$) of Uruguay in 2011?
Provide a short and direct response. 5.23e+12. What is the difference between the Value added (constant 2005 US$) in Low & middle income in 2008 and the Value added (constant 2005 US$) in West Bank and Gaza in 2011?
Offer a very short reply. 5.24e+12. What is the difference between the Value added (constant 2005 US$) in Middle East & North Africa (developing only) in 2008 and the Value added (constant 2005 US$) in Uruguay in 2011?
Provide a succinct answer. 3.45e+11. What is the difference between the Value added (constant 2005 US$) in Middle East & North Africa (developing only) in 2008 and the Value added (constant 2005 US$) in West Bank and Gaza in 2011?
Make the answer very short. 3.55e+11. What is the difference between the Value added (constant 2005 US$) in Uruguay in 2008 and the Value added (constant 2005 US$) in West Bank and Gaza in 2011?
Your answer should be very brief. 8.14e+09. What is the difference between the Value added (constant 2005 US$) in Low & middle income in 2009 and the Value added (constant 2005 US$) in Middle East & North Africa (developing only) in 2010?
Your answer should be very brief. 5.06e+12. What is the difference between the Value added (constant 2005 US$) of Low & middle income in 2009 and the Value added (constant 2005 US$) of Uruguay in 2010?
Offer a terse response. 5.44e+12. What is the difference between the Value added (constant 2005 US$) in Low & middle income in 2009 and the Value added (constant 2005 US$) in West Bank and Gaza in 2010?
Your answer should be very brief. 5.45e+12. What is the difference between the Value added (constant 2005 US$) in Middle East & North Africa (developing only) in 2009 and the Value added (constant 2005 US$) in Uruguay in 2010?
Offer a terse response. 3.54e+11. What is the difference between the Value added (constant 2005 US$) in Middle East & North Africa (developing only) in 2009 and the Value added (constant 2005 US$) in West Bank and Gaza in 2010?
Provide a succinct answer. 3.64e+11. What is the difference between the Value added (constant 2005 US$) of Uruguay in 2009 and the Value added (constant 2005 US$) of West Bank and Gaza in 2010?
Provide a succinct answer. 9.01e+09. What is the difference between the Value added (constant 2005 US$) of Low & middle income in 2009 and the Value added (constant 2005 US$) of Middle East & North Africa (developing only) in 2011?
Provide a short and direct response. 5.05e+12. What is the difference between the Value added (constant 2005 US$) of Low & middle income in 2009 and the Value added (constant 2005 US$) of Uruguay in 2011?
Your answer should be compact. 5.44e+12. What is the difference between the Value added (constant 2005 US$) in Low & middle income in 2009 and the Value added (constant 2005 US$) in West Bank and Gaza in 2011?
Your answer should be very brief. 5.45e+12. What is the difference between the Value added (constant 2005 US$) of Middle East & North Africa (developing only) in 2009 and the Value added (constant 2005 US$) of Uruguay in 2011?
Make the answer very short. 3.54e+11. What is the difference between the Value added (constant 2005 US$) of Middle East & North Africa (developing only) in 2009 and the Value added (constant 2005 US$) of West Bank and Gaza in 2011?
Provide a short and direct response. 3.64e+11. What is the difference between the Value added (constant 2005 US$) of Uruguay in 2009 and the Value added (constant 2005 US$) of West Bank and Gaza in 2011?
Provide a succinct answer. 8.66e+09. What is the difference between the Value added (constant 2005 US$) of Low & middle income in 2010 and the Value added (constant 2005 US$) of Middle East & North Africa (developing only) in 2011?
Your answer should be very brief. 5.44e+12. What is the difference between the Value added (constant 2005 US$) in Low & middle income in 2010 and the Value added (constant 2005 US$) in Uruguay in 2011?
Your answer should be very brief. 5.84e+12. What is the difference between the Value added (constant 2005 US$) in Low & middle income in 2010 and the Value added (constant 2005 US$) in West Bank and Gaza in 2011?
Provide a short and direct response. 5.85e+12. What is the difference between the Value added (constant 2005 US$) of Middle East & North Africa (developing only) in 2010 and the Value added (constant 2005 US$) of Uruguay in 2011?
Provide a short and direct response. 3.75e+11. What is the difference between the Value added (constant 2005 US$) of Middle East & North Africa (developing only) in 2010 and the Value added (constant 2005 US$) of West Bank and Gaza in 2011?
Your answer should be compact. 3.85e+11. What is the difference between the Value added (constant 2005 US$) in Uruguay in 2010 and the Value added (constant 2005 US$) in West Bank and Gaza in 2011?
Make the answer very short. 9.53e+09. What is the average Value added (constant 2005 US$) of Low & middle income per year?
Provide a succinct answer. 5.19e+12. What is the average Value added (constant 2005 US$) in Middle East & North Africa (developing only) per year?
Keep it short and to the point. 3.53e+11. What is the average Value added (constant 2005 US$) in Uruguay per year?
Provide a succinct answer. 1.12e+1. What is the average Value added (constant 2005 US$) in West Bank and Gaza per year?
Provide a succinct answer. 2.74e+09. In the year 2005, what is the difference between the Value added (constant 2005 US$) of Low & middle income and Value added (constant 2005 US$) of Middle East & North Africa (developing only)?
Give a very brief answer. 3.86e+12. In the year 2005, what is the difference between the Value added (constant 2005 US$) of Low & middle income and Value added (constant 2005 US$) of Uruguay?
Your response must be concise. 4.15e+12. In the year 2005, what is the difference between the Value added (constant 2005 US$) of Low & middle income and Value added (constant 2005 US$) of West Bank and Gaza?
Offer a very short reply. 4.16e+12. In the year 2005, what is the difference between the Value added (constant 2005 US$) in Middle East & North Africa (developing only) and Value added (constant 2005 US$) in Uruguay?
Offer a very short reply. 2.88e+11. In the year 2005, what is the difference between the Value added (constant 2005 US$) in Middle East & North Africa (developing only) and Value added (constant 2005 US$) in West Bank and Gaza?
Your response must be concise. 2.95e+11. In the year 2005, what is the difference between the Value added (constant 2005 US$) in Uruguay and Value added (constant 2005 US$) in West Bank and Gaza?
Ensure brevity in your answer.  6.60e+09. In the year 2006, what is the difference between the Value added (constant 2005 US$) in Low & middle income and Value added (constant 2005 US$) in Middle East & North Africa (developing only)?
Offer a terse response. 4.17e+12. In the year 2006, what is the difference between the Value added (constant 2005 US$) in Low & middle income and Value added (constant 2005 US$) in Uruguay?
Offer a terse response. 4.48e+12. In the year 2006, what is the difference between the Value added (constant 2005 US$) of Low & middle income and Value added (constant 2005 US$) of West Bank and Gaza?
Your answer should be very brief. 4.48e+12. In the year 2006, what is the difference between the Value added (constant 2005 US$) in Middle East & North Africa (developing only) and Value added (constant 2005 US$) in Uruguay?
Keep it short and to the point. 3.06e+11. In the year 2006, what is the difference between the Value added (constant 2005 US$) of Middle East & North Africa (developing only) and Value added (constant 2005 US$) of West Bank and Gaza?
Provide a short and direct response. 3.13e+11. In the year 2006, what is the difference between the Value added (constant 2005 US$) in Uruguay and Value added (constant 2005 US$) in West Bank and Gaza?
Your answer should be compact. 6.89e+09. In the year 2007, what is the difference between the Value added (constant 2005 US$) in Low & middle income and Value added (constant 2005 US$) in Middle East & North Africa (developing only)?
Give a very brief answer. 4.57e+12. In the year 2007, what is the difference between the Value added (constant 2005 US$) in Low & middle income and Value added (constant 2005 US$) in Uruguay?
Your answer should be compact. 4.90e+12. In the year 2007, what is the difference between the Value added (constant 2005 US$) in Low & middle income and Value added (constant 2005 US$) in West Bank and Gaza?
Your answer should be very brief. 4.91e+12. In the year 2007, what is the difference between the Value added (constant 2005 US$) in Middle East & North Africa (developing only) and Value added (constant 2005 US$) in Uruguay?
Provide a short and direct response. 3.31e+11. In the year 2007, what is the difference between the Value added (constant 2005 US$) in Middle East & North Africa (developing only) and Value added (constant 2005 US$) in West Bank and Gaza?
Your answer should be compact. 3.39e+11. In the year 2007, what is the difference between the Value added (constant 2005 US$) of Uruguay and Value added (constant 2005 US$) of West Bank and Gaza?
Provide a succinct answer. 7.62e+09. In the year 2008, what is the difference between the Value added (constant 2005 US$) of Low & middle income and Value added (constant 2005 US$) of Middle East & North Africa (developing only)?
Provide a succinct answer. 4.89e+12. In the year 2008, what is the difference between the Value added (constant 2005 US$) in Low & middle income and Value added (constant 2005 US$) in Uruguay?
Give a very brief answer. 5.23e+12. In the year 2008, what is the difference between the Value added (constant 2005 US$) of Low & middle income and Value added (constant 2005 US$) of West Bank and Gaza?
Offer a very short reply. 5.24e+12. In the year 2008, what is the difference between the Value added (constant 2005 US$) in Middle East & North Africa (developing only) and Value added (constant 2005 US$) in Uruguay?
Make the answer very short. 3.47e+11. In the year 2008, what is the difference between the Value added (constant 2005 US$) in Middle East & North Africa (developing only) and Value added (constant 2005 US$) in West Bank and Gaza?
Provide a short and direct response. 3.56e+11. In the year 2008, what is the difference between the Value added (constant 2005 US$) in Uruguay and Value added (constant 2005 US$) in West Bank and Gaza?
Provide a short and direct response. 9.01e+09. In the year 2009, what is the difference between the Value added (constant 2005 US$) in Low & middle income and Value added (constant 2005 US$) in Middle East & North Africa (developing only)?
Offer a very short reply. 5.08e+12. In the year 2009, what is the difference between the Value added (constant 2005 US$) in Low & middle income and Value added (constant 2005 US$) in Uruguay?
Make the answer very short. 5.44e+12. In the year 2009, what is the difference between the Value added (constant 2005 US$) in Low & middle income and Value added (constant 2005 US$) in West Bank and Gaza?
Your answer should be compact. 5.45e+12. In the year 2009, what is the difference between the Value added (constant 2005 US$) in Middle East & North Africa (developing only) and Value added (constant 2005 US$) in Uruguay?
Your response must be concise. 3.55e+11. In the year 2009, what is the difference between the Value added (constant 2005 US$) in Middle East & North Africa (developing only) and Value added (constant 2005 US$) in West Bank and Gaza?
Your answer should be very brief. 3.64e+11. In the year 2009, what is the difference between the Value added (constant 2005 US$) of Uruguay and Value added (constant 2005 US$) of West Bank and Gaza?
Your answer should be compact. 9.12e+09. In the year 2010, what is the difference between the Value added (constant 2005 US$) in Low & middle income and Value added (constant 2005 US$) in Middle East & North Africa (developing only)?
Give a very brief answer. 5.46e+12. In the year 2010, what is the difference between the Value added (constant 2005 US$) of Low & middle income and Value added (constant 2005 US$) of Uruguay?
Offer a terse response. 5.84e+12. In the year 2010, what is the difference between the Value added (constant 2005 US$) of Low & middle income and Value added (constant 2005 US$) of West Bank and Gaza?
Make the answer very short. 5.85e+12. In the year 2010, what is the difference between the Value added (constant 2005 US$) in Middle East & North Africa (developing only) and Value added (constant 2005 US$) in Uruguay?
Make the answer very short. 3.75e+11. In the year 2010, what is the difference between the Value added (constant 2005 US$) of Middle East & North Africa (developing only) and Value added (constant 2005 US$) of West Bank and Gaza?
Offer a very short reply. 3.85e+11. In the year 2010, what is the difference between the Value added (constant 2005 US$) in Uruguay and Value added (constant 2005 US$) in West Bank and Gaza?
Provide a succinct answer. 9.87e+09. In the year 2011, what is the difference between the Value added (constant 2005 US$) in Low & middle income and Value added (constant 2005 US$) in Middle East & North Africa (developing only)?
Provide a short and direct response. 5.83e+12. In the year 2011, what is the difference between the Value added (constant 2005 US$) in Low & middle income and Value added (constant 2005 US$) in Uruguay?
Offer a terse response. 6.22e+12. In the year 2011, what is the difference between the Value added (constant 2005 US$) of Low & middle income and Value added (constant 2005 US$) of West Bank and Gaza?
Provide a succinct answer. 6.23e+12. In the year 2011, what is the difference between the Value added (constant 2005 US$) in Middle East & North Africa (developing only) and Value added (constant 2005 US$) in Uruguay?
Ensure brevity in your answer.  3.91e+11. In the year 2011, what is the difference between the Value added (constant 2005 US$) of Middle East & North Africa (developing only) and Value added (constant 2005 US$) of West Bank and Gaza?
Keep it short and to the point. 4.01e+11. In the year 2011, what is the difference between the Value added (constant 2005 US$) in Uruguay and Value added (constant 2005 US$) in West Bank and Gaza?
Your answer should be very brief. 1.02e+1. What is the ratio of the Value added (constant 2005 US$) of Low & middle income in 2005 to that in 2006?
Provide a succinct answer. 0.93. What is the ratio of the Value added (constant 2005 US$) of Middle East & North Africa (developing only) in 2005 to that in 2006?
Your answer should be compact. 0.94. What is the ratio of the Value added (constant 2005 US$) of Uruguay in 2005 to that in 2006?
Provide a short and direct response. 0.97. What is the ratio of the Value added (constant 2005 US$) of West Bank and Gaza in 2005 to that in 2006?
Offer a terse response. 1.01. What is the ratio of the Value added (constant 2005 US$) in Low & middle income in 2005 to that in 2007?
Make the answer very short. 0.85. What is the ratio of the Value added (constant 2005 US$) of Middle East & North Africa (developing only) in 2005 to that in 2007?
Give a very brief answer. 0.87. What is the ratio of the Value added (constant 2005 US$) in Uruguay in 2005 to that in 2007?
Offer a very short reply. 0.92. What is the ratio of the Value added (constant 2005 US$) of West Bank and Gaza in 2005 to that in 2007?
Provide a short and direct response. 1.07. What is the ratio of the Value added (constant 2005 US$) in Low & middle income in 2005 to that in 2008?
Provide a succinct answer. 0.79. What is the ratio of the Value added (constant 2005 US$) of Middle East & North Africa (developing only) in 2005 to that in 2008?
Give a very brief answer. 0.83. What is the ratio of the Value added (constant 2005 US$) in Uruguay in 2005 to that in 2008?
Offer a terse response. 0.83. What is the ratio of the Value added (constant 2005 US$) in West Bank and Gaza in 2005 to that in 2008?
Offer a terse response. 1.23. What is the ratio of the Value added (constant 2005 US$) of Low & middle income in 2005 to that in 2009?
Your answer should be very brief. 0.76. What is the ratio of the Value added (constant 2005 US$) in Middle East & North Africa (developing only) in 2005 to that in 2009?
Your answer should be compact. 0.81. What is the ratio of the Value added (constant 2005 US$) in Uruguay in 2005 to that in 2009?
Make the answer very short. 0.8. What is the ratio of the Value added (constant 2005 US$) of West Bank and Gaza in 2005 to that in 2009?
Your answer should be compact. 1.04. What is the ratio of the Value added (constant 2005 US$) in Low & middle income in 2005 to that in 2010?
Offer a very short reply. 0.71. What is the ratio of the Value added (constant 2005 US$) in Middle East & North Africa (developing only) in 2005 to that in 2010?
Ensure brevity in your answer.  0.77. What is the ratio of the Value added (constant 2005 US$) in Uruguay in 2005 to that in 2010?
Keep it short and to the point. 0.74. What is the ratio of the Value added (constant 2005 US$) of West Bank and Gaza in 2005 to that in 2010?
Offer a very short reply. 1. What is the ratio of the Value added (constant 2005 US$) in Low & middle income in 2005 to that in 2011?
Your answer should be compact. 0.67. What is the ratio of the Value added (constant 2005 US$) in Middle East & North Africa (developing only) in 2005 to that in 2011?
Your answer should be very brief. 0.73. What is the ratio of the Value added (constant 2005 US$) in Uruguay in 2005 to that in 2011?
Give a very brief answer. 0.7. What is the ratio of the Value added (constant 2005 US$) of West Bank and Gaza in 2005 to that in 2011?
Your response must be concise. 0.89. What is the ratio of the Value added (constant 2005 US$) in Low & middle income in 2006 to that in 2007?
Provide a short and direct response. 0.91. What is the ratio of the Value added (constant 2005 US$) of Middle East & North Africa (developing only) in 2006 to that in 2007?
Offer a terse response. 0.92. What is the ratio of the Value added (constant 2005 US$) in Uruguay in 2006 to that in 2007?
Your answer should be compact. 0.94. What is the ratio of the Value added (constant 2005 US$) of West Bank and Gaza in 2006 to that in 2007?
Give a very brief answer. 1.06. What is the ratio of the Value added (constant 2005 US$) of Low & middle income in 2006 to that in 2008?
Ensure brevity in your answer.  0.86. What is the ratio of the Value added (constant 2005 US$) in Middle East & North Africa (developing only) in 2006 to that in 2008?
Offer a terse response. 0.88. What is the ratio of the Value added (constant 2005 US$) in Uruguay in 2006 to that in 2008?
Your answer should be very brief. 0.86. What is the ratio of the Value added (constant 2005 US$) in West Bank and Gaza in 2006 to that in 2008?
Provide a succinct answer. 1.22. What is the ratio of the Value added (constant 2005 US$) of Low & middle income in 2006 to that in 2009?
Ensure brevity in your answer.  0.82. What is the ratio of the Value added (constant 2005 US$) in Middle East & North Africa (developing only) in 2006 to that in 2009?
Provide a short and direct response. 0.86. What is the ratio of the Value added (constant 2005 US$) of Uruguay in 2006 to that in 2009?
Offer a very short reply. 0.82. What is the ratio of the Value added (constant 2005 US$) in West Bank and Gaza in 2006 to that in 2009?
Keep it short and to the point. 1.03. What is the ratio of the Value added (constant 2005 US$) in Low & middle income in 2006 to that in 2010?
Your response must be concise. 0.77. What is the ratio of the Value added (constant 2005 US$) of Middle East & North Africa (developing only) in 2006 to that in 2010?
Ensure brevity in your answer.  0.81. What is the ratio of the Value added (constant 2005 US$) in Uruguay in 2006 to that in 2010?
Provide a short and direct response. 0.76. What is the ratio of the Value added (constant 2005 US$) in West Bank and Gaza in 2006 to that in 2010?
Offer a very short reply. 0.99. What is the ratio of the Value added (constant 2005 US$) of Low & middle income in 2006 to that in 2011?
Provide a short and direct response. 0.72. What is the ratio of the Value added (constant 2005 US$) of Middle East & North Africa (developing only) in 2006 to that in 2011?
Make the answer very short. 0.78. What is the ratio of the Value added (constant 2005 US$) of Uruguay in 2006 to that in 2011?
Provide a short and direct response. 0.72. What is the ratio of the Value added (constant 2005 US$) in West Bank and Gaza in 2006 to that in 2011?
Ensure brevity in your answer.  0.88. What is the ratio of the Value added (constant 2005 US$) of Low & middle income in 2007 to that in 2008?
Ensure brevity in your answer.  0.94. What is the ratio of the Value added (constant 2005 US$) in Middle East & North Africa (developing only) in 2007 to that in 2008?
Give a very brief answer. 0.95. What is the ratio of the Value added (constant 2005 US$) in Uruguay in 2007 to that in 2008?
Ensure brevity in your answer.  0.91. What is the ratio of the Value added (constant 2005 US$) in West Bank and Gaza in 2007 to that in 2008?
Your answer should be compact. 1.16. What is the ratio of the Value added (constant 2005 US$) in Low & middle income in 2007 to that in 2009?
Your response must be concise. 0.9. What is the ratio of the Value added (constant 2005 US$) in Middle East & North Africa (developing only) in 2007 to that in 2009?
Make the answer very short. 0.93. What is the ratio of the Value added (constant 2005 US$) of Uruguay in 2007 to that in 2009?
Your response must be concise. 0.87. What is the ratio of the Value added (constant 2005 US$) of West Bank and Gaza in 2007 to that in 2009?
Your response must be concise. 0.98. What is the ratio of the Value added (constant 2005 US$) in Low & middle income in 2007 to that in 2010?
Make the answer very short. 0.84. What is the ratio of the Value added (constant 2005 US$) in Middle East & North Africa (developing only) in 2007 to that in 2010?
Provide a succinct answer. 0.88. What is the ratio of the Value added (constant 2005 US$) in Uruguay in 2007 to that in 2010?
Your answer should be very brief. 0.81. What is the ratio of the Value added (constant 2005 US$) in West Bank and Gaza in 2007 to that in 2010?
Your answer should be very brief. 0.94. What is the ratio of the Value added (constant 2005 US$) of Low & middle income in 2007 to that in 2011?
Give a very brief answer. 0.79. What is the ratio of the Value added (constant 2005 US$) of Middle East & North Africa (developing only) in 2007 to that in 2011?
Give a very brief answer. 0.84. What is the ratio of the Value added (constant 2005 US$) of Uruguay in 2007 to that in 2011?
Provide a succinct answer. 0.77. What is the ratio of the Value added (constant 2005 US$) in West Bank and Gaza in 2007 to that in 2011?
Keep it short and to the point. 0.84. What is the ratio of the Value added (constant 2005 US$) in Low & middle income in 2008 to that in 2009?
Offer a very short reply. 0.96. What is the ratio of the Value added (constant 2005 US$) in Middle East & North Africa (developing only) in 2008 to that in 2009?
Your answer should be compact. 0.98. What is the ratio of the Value added (constant 2005 US$) of Uruguay in 2008 to that in 2009?
Keep it short and to the point. 0.96. What is the ratio of the Value added (constant 2005 US$) in West Bank and Gaza in 2008 to that in 2009?
Give a very brief answer. 0.85. What is the ratio of the Value added (constant 2005 US$) of Low & middle income in 2008 to that in 2010?
Offer a terse response. 0.9. What is the ratio of the Value added (constant 2005 US$) of Uruguay in 2008 to that in 2010?
Make the answer very short. 0.89. What is the ratio of the Value added (constant 2005 US$) in West Bank and Gaza in 2008 to that in 2010?
Ensure brevity in your answer.  0.81. What is the ratio of the Value added (constant 2005 US$) of Low & middle income in 2008 to that in 2011?
Your answer should be very brief. 0.84. What is the ratio of the Value added (constant 2005 US$) of Middle East & North Africa (developing only) in 2008 to that in 2011?
Make the answer very short. 0.89. What is the ratio of the Value added (constant 2005 US$) of Uruguay in 2008 to that in 2011?
Keep it short and to the point. 0.84. What is the ratio of the Value added (constant 2005 US$) in West Bank and Gaza in 2008 to that in 2011?
Provide a short and direct response. 0.72. What is the ratio of the Value added (constant 2005 US$) of Low & middle income in 2009 to that in 2010?
Give a very brief answer. 0.93. What is the ratio of the Value added (constant 2005 US$) of Middle East & North Africa (developing only) in 2009 to that in 2010?
Make the answer very short. 0.95. What is the ratio of the Value added (constant 2005 US$) in Uruguay in 2009 to that in 2010?
Provide a short and direct response. 0.93. What is the ratio of the Value added (constant 2005 US$) in West Bank and Gaza in 2009 to that in 2010?
Give a very brief answer. 0.96. What is the ratio of the Value added (constant 2005 US$) of Low & middle income in 2009 to that in 2011?
Provide a short and direct response. 0.87. What is the ratio of the Value added (constant 2005 US$) of Middle East & North Africa (developing only) in 2009 to that in 2011?
Your answer should be very brief. 0.91. What is the ratio of the Value added (constant 2005 US$) of Uruguay in 2009 to that in 2011?
Your response must be concise. 0.88. What is the ratio of the Value added (constant 2005 US$) of West Bank and Gaza in 2009 to that in 2011?
Make the answer very short. 0.85. What is the ratio of the Value added (constant 2005 US$) of Low & middle income in 2010 to that in 2011?
Give a very brief answer. 0.94. What is the ratio of the Value added (constant 2005 US$) of Uruguay in 2010 to that in 2011?
Your response must be concise. 0.95. What is the ratio of the Value added (constant 2005 US$) of West Bank and Gaza in 2010 to that in 2011?
Provide a succinct answer. 0.89. What is the difference between the highest and the second highest Value added (constant 2005 US$) in Low & middle income?
Your answer should be compact. 3.83e+11. What is the difference between the highest and the second highest Value added (constant 2005 US$) in Middle East & North Africa (developing only)?
Make the answer very short. 1.66e+1. What is the difference between the highest and the second highest Value added (constant 2005 US$) in Uruguay?
Provide a short and direct response. 7.06e+08. What is the difference between the highest and the second highest Value added (constant 2005 US$) in West Bank and Gaza?
Give a very brief answer. 3.43e+08. What is the difference between the highest and the lowest Value added (constant 2005 US$) of Low & middle income?
Your response must be concise. 2.07e+12. What is the difference between the highest and the lowest Value added (constant 2005 US$) of Middle East & North Africa (developing only)?
Provide a succinct answer. 1.07e+11. What is the difference between the highest and the lowest Value added (constant 2005 US$) of Uruguay?
Your answer should be very brief. 3.97e+09. What is the difference between the highest and the lowest Value added (constant 2005 US$) of West Bank and Gaza?
Your response must be concise. 8.71e+08. 